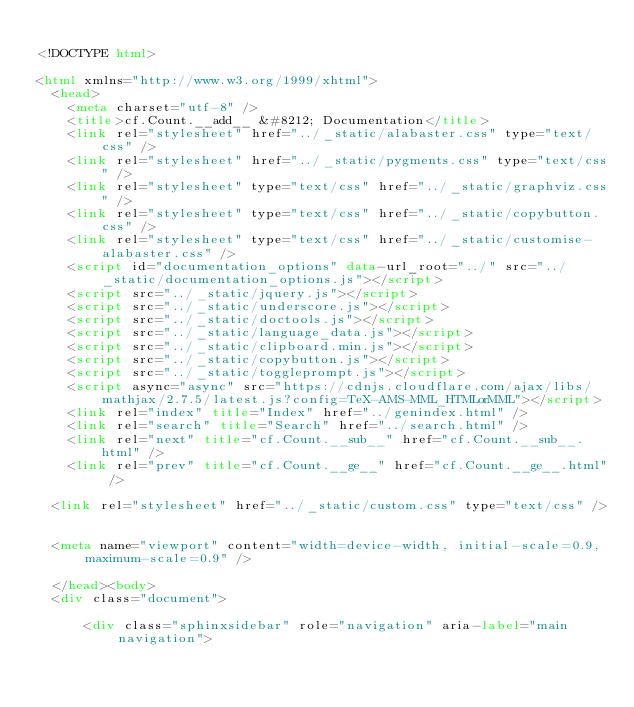<code> <loc_0><loc_0><loc_500><loc_500><_HTML_>
<!DOCTYPE html>

<html xmlns="http://www.w3.org/1999/xhtml">
  <head>
    <meta charset="utf-8" />
    <title>cf.Count.__add__ &#8212; Documentation</title>
    <link rel="stylesheet" href="../_static/alabaster.css" type="text/css" />
    <link rel="stylesheet" href="../_static/pygments.css" type="text/css" />
    <link rel="stylesheet" type="text/css" href="../_static/graphviz.css" />
    <link rel="stylesheet" type="text/css" href="../_static/copybutton.css" />
    <link rel="stylesheet" type="text/css" href="../_static/customise-alabaster.css" />
    <script id="documentation_options" data-url_root="../" src="../_static/documentation_options.js"></script>
    <script src="../_static/jquery.js"></script>
    <script src="../_static/underscore.js"></script>
    <script src="../_static/doctools.js"></script>
    <script src="../_static/language_data.js"></script>
    <script src="../_static/clipboard.min.js"></script>
    <script src="../_static/copybutton.js"></script>
    <script src="../_static/toggleprompt.js"></script>
    <script async="async" src="https://cdnjs.cloudflare.com/ajax/libs/mathjax/2.7.5/latest.js?config=TeX-AMS-MML_HTMLorMML"></script>
    <link rel="index" title="Index" href="../genindex.html" />
    <link rel="search" title="Search" href="../search.html" />
    <link rel="next" title="cf.Count.__sub__" href="cf.Count.__sub__.html" />
    <link rel="prev" title="cf.Count.__ge__" href="cf.Count.__ge__.html" />
   
  <link rel="stylesheet" href="../_static/custom.css" type="text/css" />
  
  
  <meta name="viewport" content="width=device-width, initial-scale=0.9, maximum-scale=0.9" />

  </head><body>
  <div class="document">
    
      <div class="sphinxsidebar" role="navigation" aria-label="main navigation"></code> 